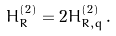<formula> <loc_0><loc_0><loc_500><loc_500>H ^ { ( 2 ) } _ { R } = 2 H ^ { ( 2 ) } _ { R , q } \, .</formula> 